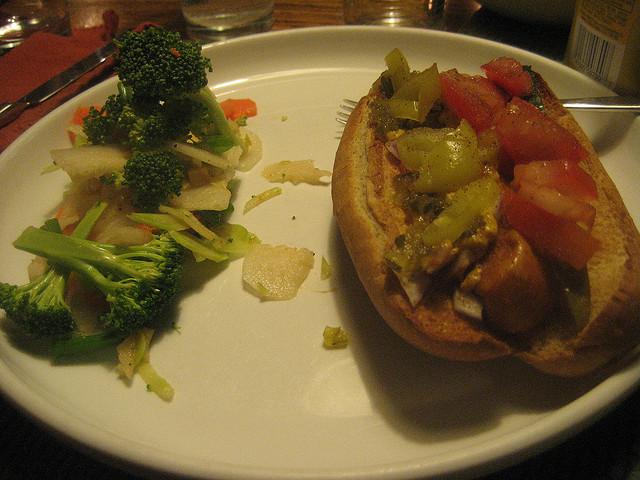Has the bun been toasted?
Answer briefly. Yes. How many meat products are on the plate?
Be succinct. 1. What utensil is hidden behind the hotdog?
Write a very short answer. Fork. 